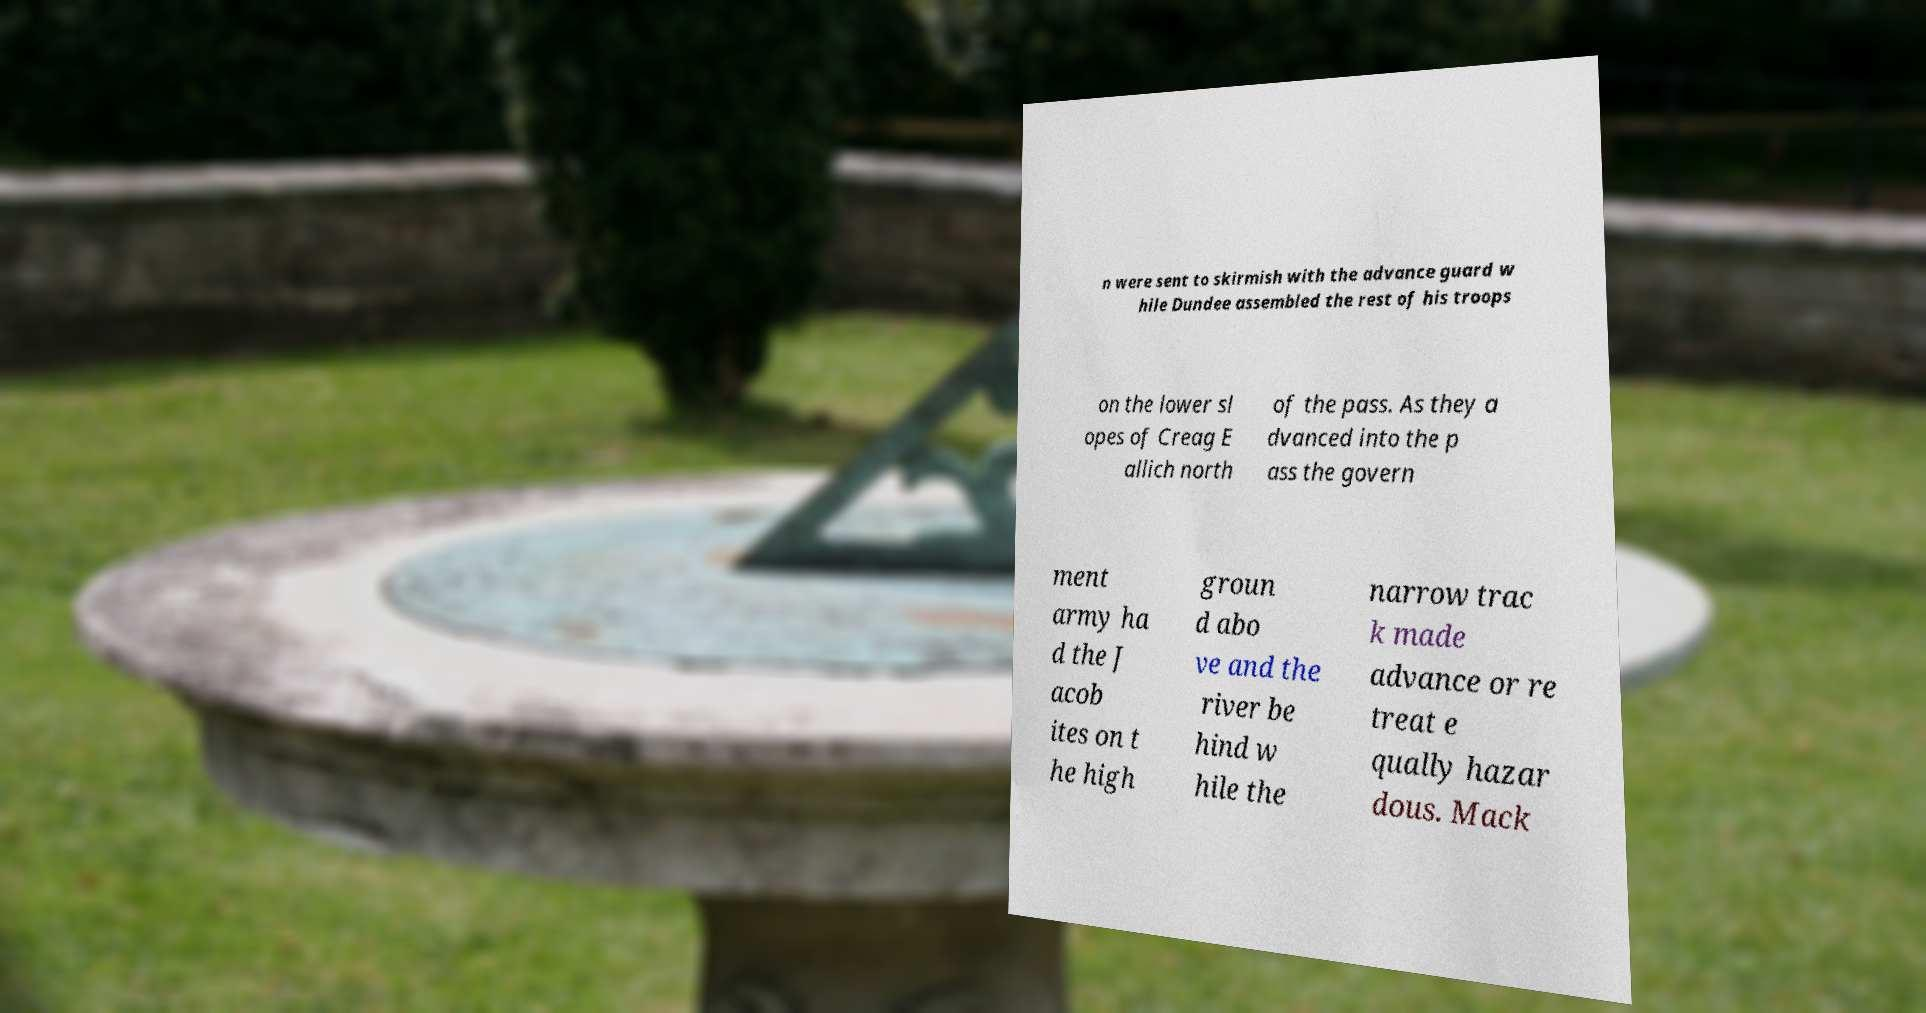Can you accurately transcribe the text from the provided image for me? n were sent to skirmish with the advance guard w hile Dundee assembled the rest of his troops on the lower sl opes of Creag E allich north of the pass. As they a dvanced into the p ass the govern ment army ha d the J acob ites on t he high groun d abo ve and the river be hind w hile the narrow trac k made advance or re treat e qually hazar dous. Mack 